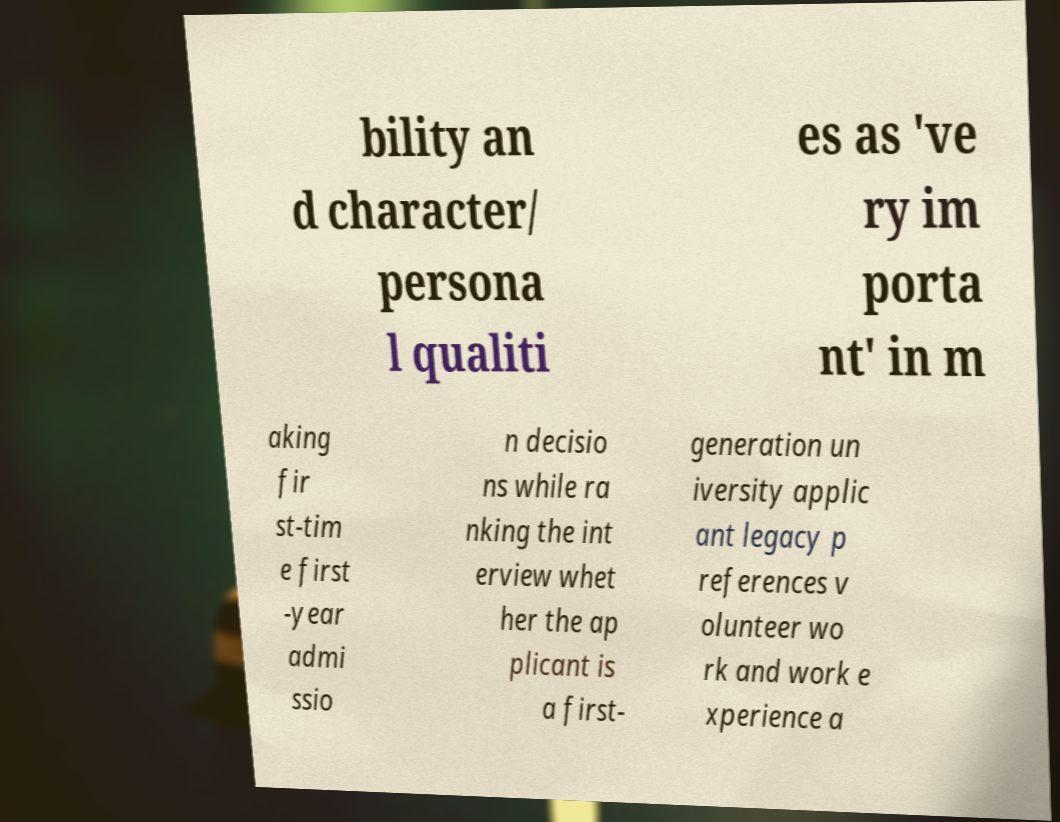There's text embedded in this image that I need extracted. Can you transcribe it verbatim? bility an d character/ persona l qualiti es as 've ry im porta nt' in m aking fir st-tim e first -year admi ssio n decisio ns while ra nking the int erview whet her the ap plicant is a first- generation un iversity applic ant legacy p references v olunteer wo rk and work e xperience a 